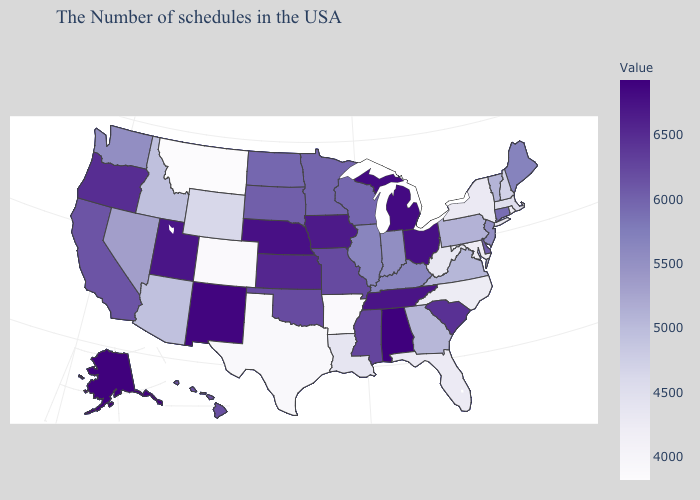Does North Dakota have a higher value than Kentucky?
Be succinct. Yes. Does Alabama have the highest value in the USA?
Keep it brief. Yes. Does Delaware have the lowest value in the South?
Be succinct. No. Does Montana have the lowest value in the West?
Keep it brief. Yes. Which states have the lowest value in the South?
Quick response, please. Arkansas. Does Arkansas have the lowest value in the South?
Keep it brief. Yes. 